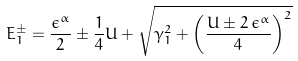<formula> <loc_0><loc_0><loc_500><loc_500>E _ { 1 } ^ { \pm } = \frac { \epsilon ^ { \alpha } } { 2 } \pm \frac { 1 } { 4 } U + \sqrt { \gamma _ { 1 } ^ { 2 } + \left ( \frac { U \pm 2 \, \epsilon ^ { \alpha } } { 4 } \right ) ^ { 2 } }</formula> 